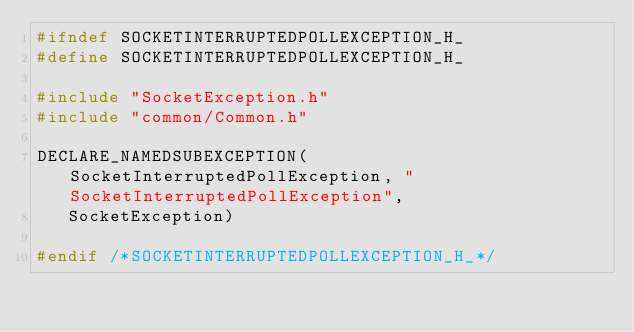<code> <loc_0><loc_0><loc_500><loc_500><_C_>#ifndef SOCKETINTERRUPTEDPOLLEXCEPTION_H_
#define SOCKETINTERRUPTEDPOLLEXCEPTION_H_

#include "SocketException.h"
#include "common/Common.h"

DECLARE_NAMEDSUBEXCEPTION(SocketInterruptedPollException, "SocketInterruptedPollException",
   SocketException)

#endif /*SOCKETINTERRUPTEDPOLLEXCEPTION_H_*/
</code> 